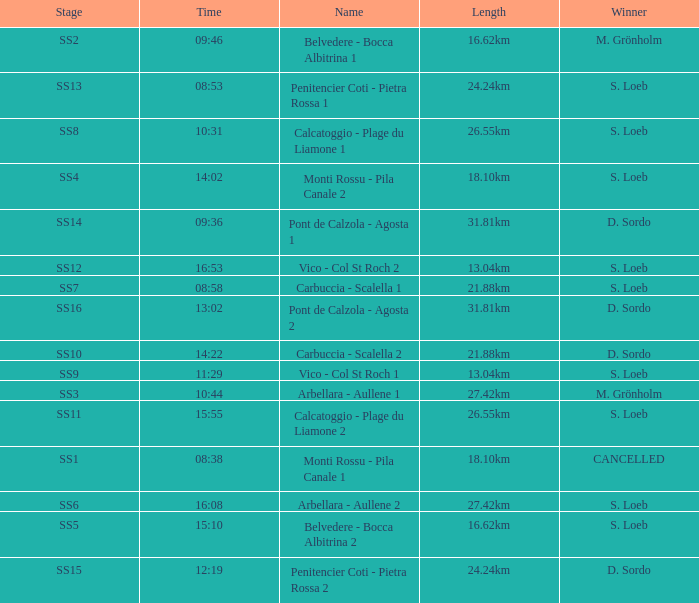What is the Name of the SS11 Stage? Calcatoggio - Plage du Liamone 2. 